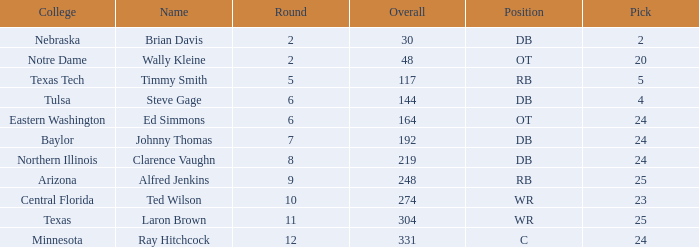What are the total rounds for the texas college and has a pick smaller than 25? 0.0. Would you be able to parse every entry in this table? {'header': ['College', 'Name', 'Round', 'Overall', 'Position', 'Pick'], 'rows': [['Nebraska', 'Brian Davis', '2', '30', 'DB', '2'], ['Notre Dame', 'Wally Kleine', '2', '48', 'OT', '20'], ['Texas Tech', 'Timmy Smith', '5', '117', 'RB', '5'], ['Tulsa', 'Steve Gage', '6', '144', 'DB', '4'], ['Eastern Washington', 'Ed Simmons', '6', '164', 'OT', '24'], ['Baylor', 'Johnny Thomas', '7', '192', 'DB', '24'], ['Northern Illinois', 'Clarence Vaughn', '8', '219', 'DB', '24'], ['Arizona', 'Alfred Jenkins', '9', '248', 'RB', '25'], ['Central Florida', 'Ted Wilson', '10', '274', 'WR', '23'], ['Texas', 'Laron Brown', '11', '304', 'WR', '25'], ['Minnesota', 'Ray Hitchcock', '12', '331', 'C', '24']]} 